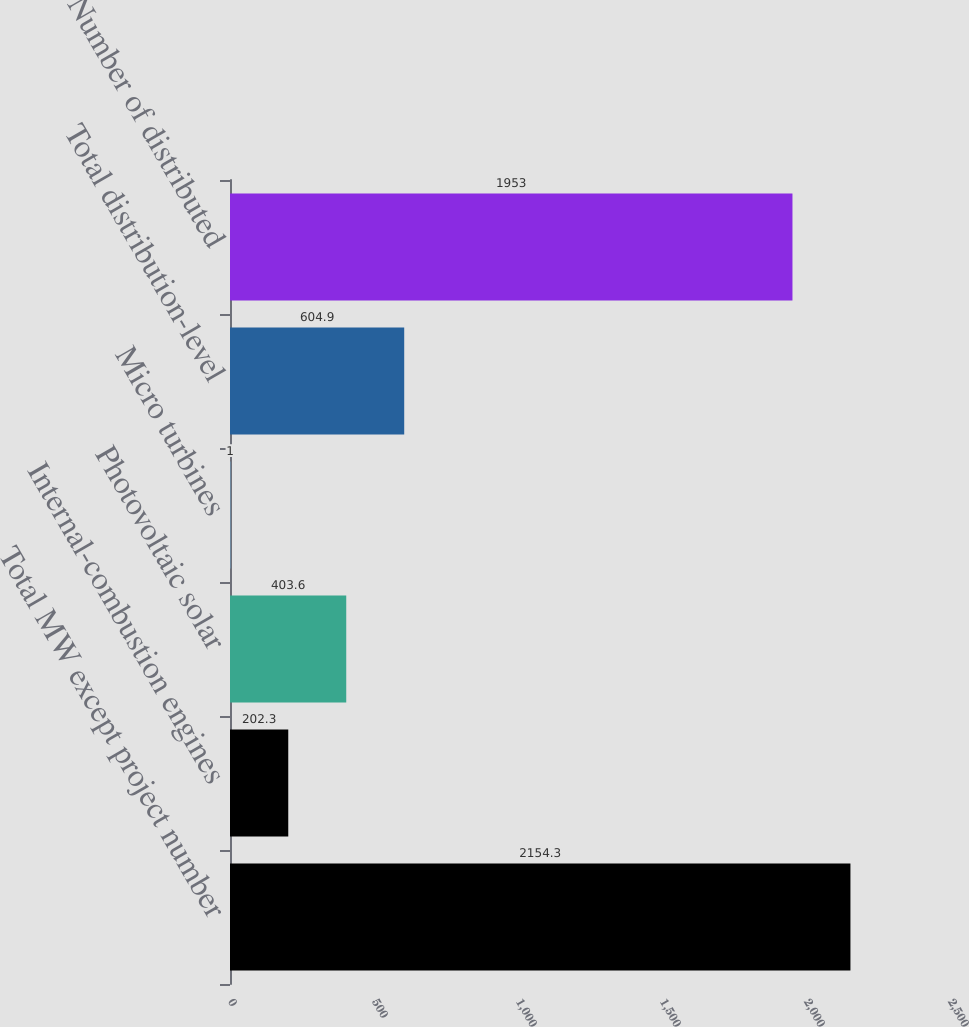Convert chart. <chart><loc_0><loc_0><loc_500><loc_500><bar_chart><fcel>Total MW except project number<fcel>Internal-combustion engines<fcel>Photovoltaic solar<fcel>Micro turbines<fcel>Total distribution-level<fcel>Number of distributed<nl><fcel>2154.3<fcel>202.3<fcel>403.6<fcel>1<fcel>604.9<fcel>1953<nl></chart> 